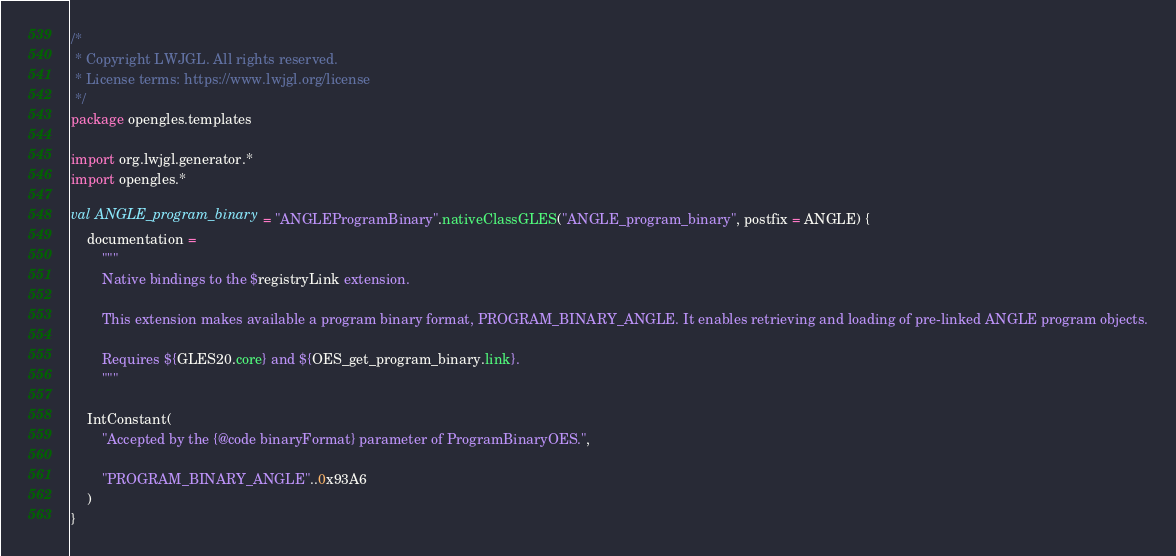Convert code to text. <code><loc_0><loc_0><loc_500><loc_500><_Kotlin_>/*
 * Copyright LWJGL. All rights reserved.
 * License terms: https://www.lwjgl.org/license
 */
package opengles.templates

import org.lwjgl.generator.*
import opengles.*

val ANGLE_program_binary = "ANGLEProgramBinary".nativeClassGLES("ANGLE_program_binary", postfix = ANGLE) {
    documentation =
        """
        Native bindings to the $registryLink extension.

        This extension makes available a program binary format, PROGRAM_BINARY_ANGLE. It enables retrieving and loading of pre-linked ANGLE program objects.

        Requires ${GLES20.core} and ${OES_get_program_binary.link}.
        """

    IntConstant(
        "Accepted by the {@code binaryFormat} parameter of ProgramBinaryOES.",

        "PROGRAM_BINARY_ANGLE"..0x93A6
    )
}</code> 